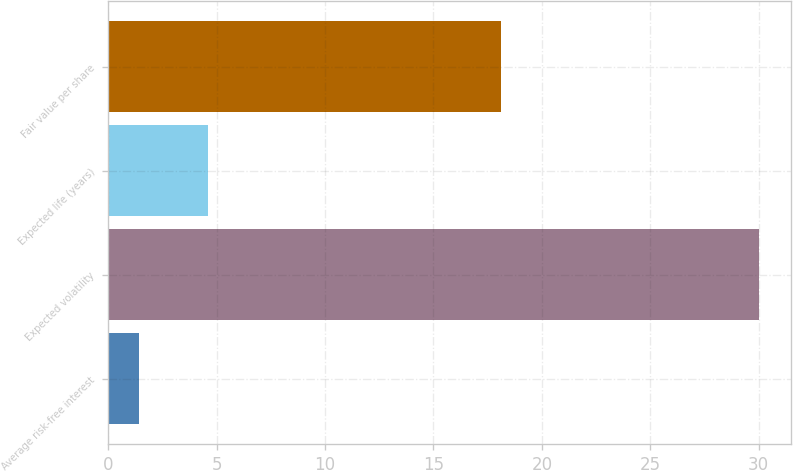Convert chart. <chart><loc_0><loc_0><loc_500><loc_500><bar_chart><fcel>Average risk-free interest<fcel>Expected volatility<fcel>Expected life (years)<fcel>Fair value per share<nl><fcel>1.4<fcel>30<fcel>4.6<fcel>18.13<nl></chart> 